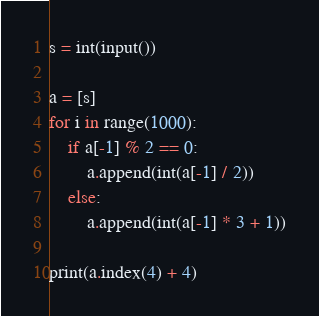<code> <loc_0><loc_0><loc_500><loc_500><_Python_>s = int(input())

a = [s]
for i in range(1000):
    if a[-1] % 2 == 0:
        a.append(int(a[-1] / 2))
    else:
        a.append(int(a[-1] * 3 + 1))

print(a.index(4) + 4)</code> 